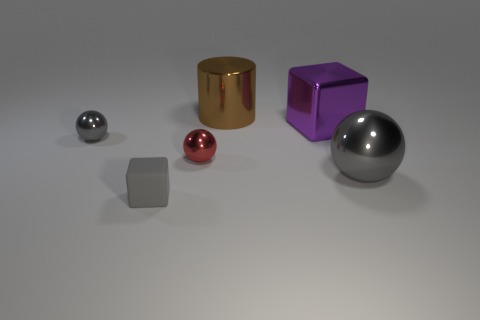Imagine if these objects represented a city's skyline, what time of day would it look like? If these objects were likened to a city's skyline, the soft lighting and shadows would suggest a time just after dawn or before dusk, likely creating a serene ambiance with the warm light gently illuminating the buildings. 